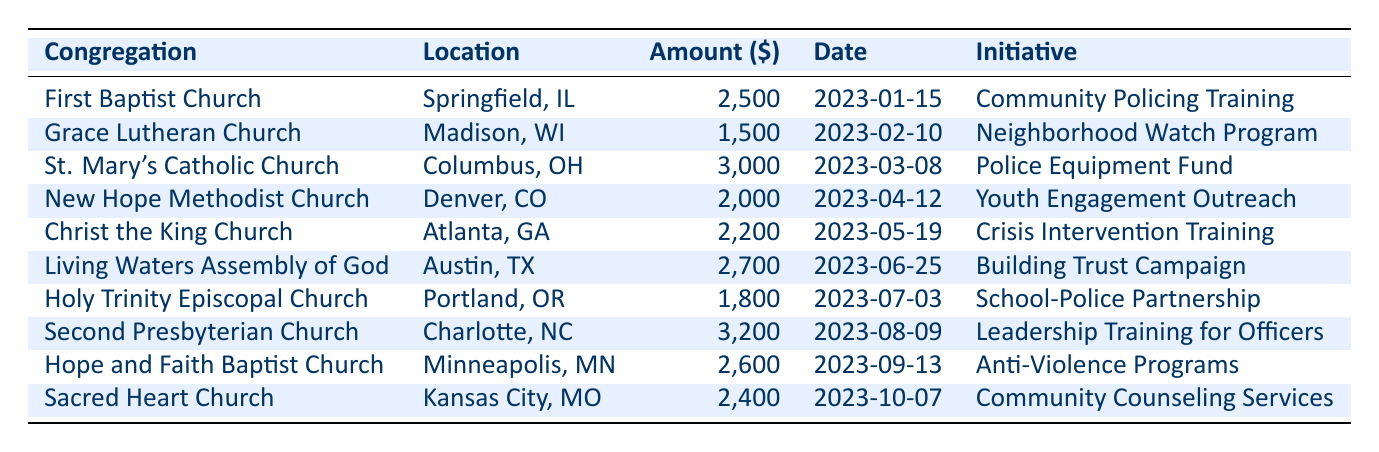What is the total amount donated by all congregations? To find the total amount, we add up all the donation amounts: 2500 + 1500 + 3000 + 2000 + 2200 + 2700 + 1800 + 3200 + 2600 + 2400 = 24,000.
Answer: 24000 Which congregation contributed the highest amount? Looking at the donation amounts listed, St. Mary's Catholic Church donated the highest amount of 3000.
Answer: St. Mary's Catholic Church How many congregations donated on or after May 1, 2023? Checking the donation dates, we see contributions from Living Waters Assembly of God (June), Second Presbyterian Church (August), Hope and Faith Baptist Church (September), and Sacred Heart Church (October) which total four congregations.
Answer: 4 Did Grace Lutheran Church donate more than $2,000? Grace Lutheran Church donated 1500, which is less than 2000, so the answer is no.
Answer: No What is the average donation amount among the congregations? To calculate the average, we first sum all the donations (24000) and divide by the number of entries (10): 24000 / 10 = 2400.
Answer: 2400 Which initiatives received contributions from congregations in the Midwest? The initiatives from Midwest congregations are: Neighborhood Watch Program (Grace Lutheran Church), Police Equipment Fund (St. Mary's Catholic Church), and Community Counseling Services (Sacred Heart Church).
Answer: 3 (initiatives) How much did the congregations in Atlanta, GA donate in total? The only congregation in Atlanta is Christ the King Church, which donated 2200, so the total is 2200.
Answer: 2200 Was the total amount donated by Holy Trinity Episcopal Church higher than the average donation amount? Holy Trinity Episcopal Church donated 1800, which is less than the average donation amount of 2400, so the answer is no.
Answer: No What is the difference in donation amounts between the highest and lowest contributions? The highest donation was 3200 from Second Presbyterian Church, and the lowest was 1500 from Grace Lutheran Church. The difference is 3200 - 1500 = 1700.
Answer: 1700 